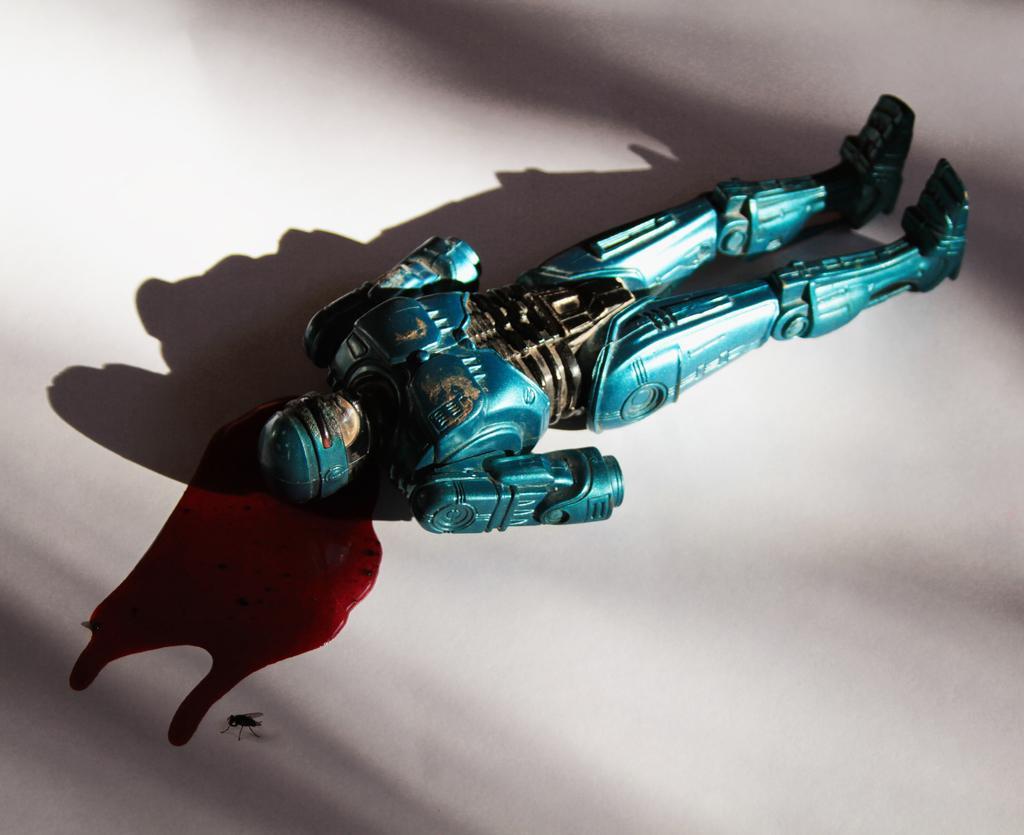Describe this image in one or two sentences. Here we can see toy,blood and fly on white surface 